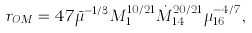Convert formula to latex. <formula><loc_0><loc_0><loc_500><loc_500>r _ { O M } = 4 7 \bar { \mu } ^ { - 1 / 3 } M _ { 1 } ^ { 1 0 / 2 1 } \dot { M } _ { 1 4 } ^ { 2 0 / 2 1 } \mu _ { 1 6 } ^ { - 4 / 7 } ,</formula> 